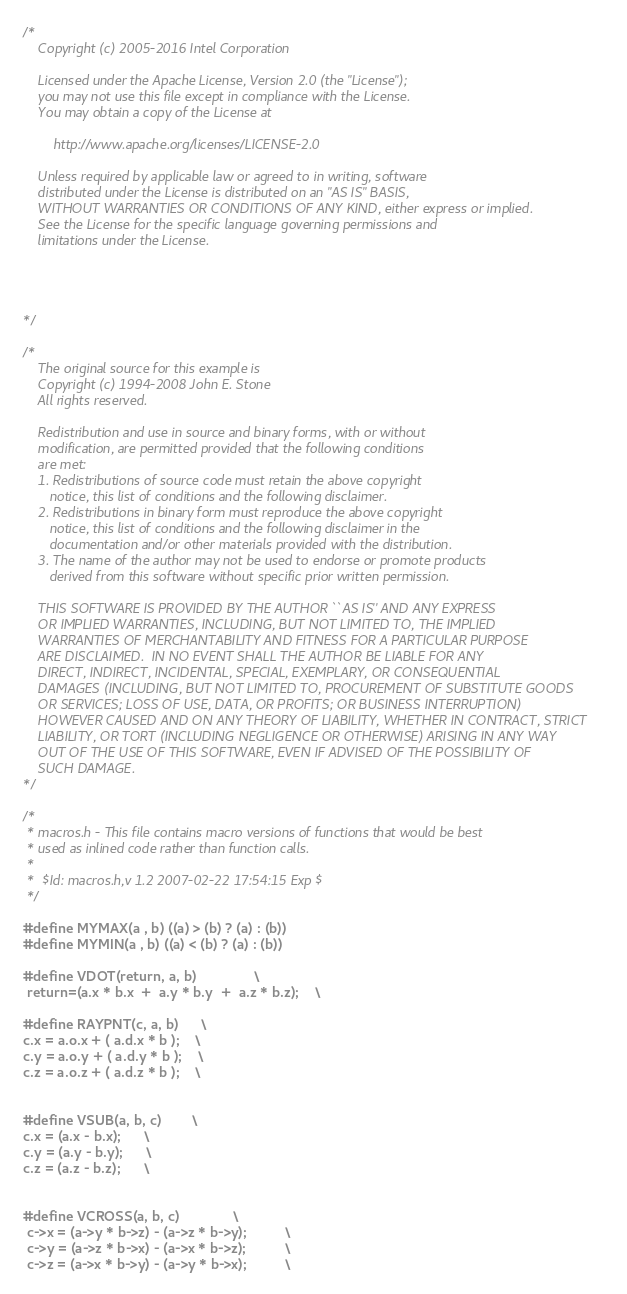Convert code to text. <code><loc_0><loc_0><loc_500><loc_500><_C_>/*
    Copyright (c) 2005-2016 Intel Corporation

    Licensed under the Apache License, Version 2.0 (the "License");
    you may not use this file except in compliance with the License.
    You may obtain a copy of the License at

        http://www.apache.org/licenses/LICENSE-2.0

    Unless required by applicable law or agreed to in writing, software
    distributed under the License is distributed on an "AS IS" BASIS,
    WITHOUT WARRANTIES OR CONDITIONS OF ANY KIND, either express or implied.
    See the License for the specific language governing permissions and
    limitations under the License.




*/

/*
    The original source for this example is
    Copyright (c) 1994-2008 John E. Stone
    All rights reserved.

    Redistribution and use in source and binary forms, with or without
    modification, are permitted provided that the following conditions
    are met:
    1. Redistributions of source code must retain the above copyright
       notice, this list of conditions and the following disclaimer.
    2. Redistributions in binary form must reproduce the above copyright
       notice, this list of conditions and the following disclaimer in the
       documentation and/or other materials provided with the distribution.
    3. The name of the author may not be used to endorse or promote products
       derived from this software without specific prior written permission.

    THIS SOFTWARE IS PROVIDED BY THE AUTHOR ``AS IS'' AND ANY EXPRESS
    OR IMPLIED WARRANTIES, INCLUDING, BUT NOT LIMITED TO, THE IMPLIED
    WARRANTIES OF MERCHANTABILITY AND FITNESS FOR A PARTICULAR PURPOSE
    ARE DISCLAIMED.  IN NO EVENT SHALL THE AUTHOR BE LIABLE FOR ANY
    DIRECT, INDIRECT, INCIDENTAL, SPECIAL, EXEMPLARY, OR CONSEQUENTIAL
    DAMAGES (INCLUDING, BUT NOT LIMITED TO, PROCUREMENT OF SUBSTITUTE GOODS
    OR SERVICES; LOSS OF USE, DATA, OR PROFITS; OR BUSINESS INTERRUPTION)
    HOWEVER CAUSED AND ON ANY THEORY OF LIABILITY, WHETHER IN CONTRACT, STRICT
    LIABILITY, OR TORT (INCLUDING NEGLIGENCE OR OTHERWISE) ARISING IN ANY WAY
    OUT OF THE USE OF THIS SOFTWARE, EVEN IF ADVISED OF THE POSSIBILITY OF
    SUCH DAMAGE.
*/

/* 
 * macros.h - This file contains macro versions of functions that would be best 
 * used as inlined code rather than function calls.
 *
 *  $Id: macros.h,v 1.2 2007-02-22 17:54:15 Exp $
 */

#define MYMAX(a , b) ((a) > (b) ? (a) : (b))
#define MYMIN(a , b) ((a) < (b) ? (a) : (b))

#define VDOT(return, a, b) 				\
 return=(a.x * b.x  +  a.y * b.y  +  a.z * b.z); 	\

#define RAYPNT(c, a, b)		\
c.x = a.o.x + ( a.d.x * b );	\
c.y = a.o.y + ( a.d.y * b );	\
c.z = a.o.z + ( a.d.z * b );	\


#define VSUB(a, b, c)		\
c.x = (a.x - b.x);		\
c.y = (a.y - b.y);		\
c.z = (a.z - b.z);		\


#define VCROSS(a, b, c) 				\
 c->x = (a->y * b->z) - (a->z * b->y);			\
 c->y = (a->z * b->x) - (a->x * b->z);			\
 c->z = (a->x * b->y) - (a->y * b->x);			\

</code> 